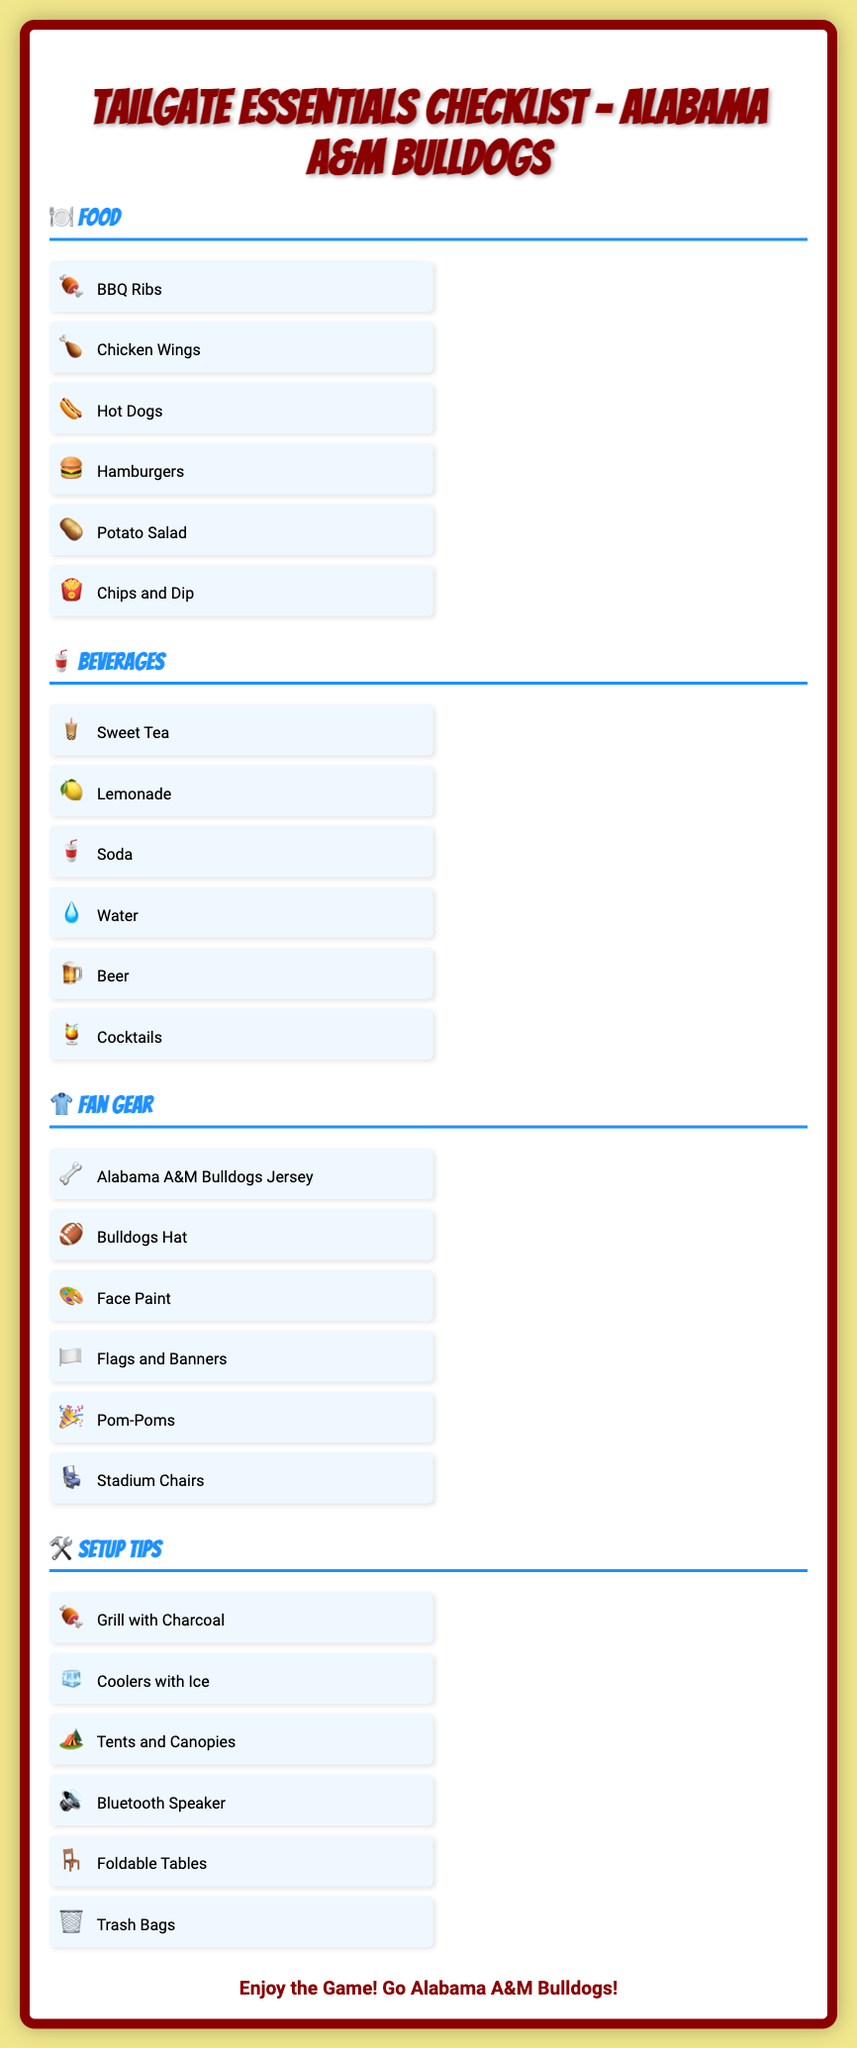What is the title of the poster? The title of the poster clearly states the theme and content of the document.
Answer: Tailgate Essentials Checklist – Alabama A&M Bulldogs How many food items are listed? The section under Food includes a list of items that can be tallied for a total count.
Answer: 6 What beverage is specified first? The beverages are listed in a specific order, so the first item can be identified.
Answer: Sweet Tea Which fan gear item represents the Bulldogs? The poster lists various items under fan gear, and one can identify the item that represents the team.
Answer: Alabama A&M Bulldogs Jersey What type of speaker is suggested in the setup tips? The setup tips include advice on what technology to bring, including speakers, which can be directly quoted.
Answer: Bluetooth Speaker How many setup tips are provided? Similar to the food and beverages, this can be counted from the listed items in the setup tips section.
Answer: 6 What is the color theme of the poster background? The background color is described in the document's styling and helps set the poster's mood.
Answer: Yellow What type of trash management item is mentioned? The document discusses organization and clean-up, mentioning the type of trash management tool necessary.
Answer: Trash Bags 